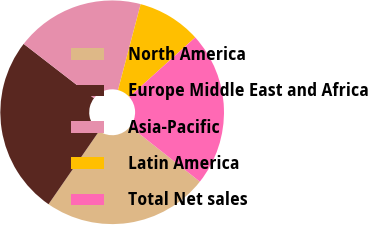Convert chart. <chart><loc_0><loc_0><loc_500><loc_500><pie_chart><fcel>North America<fcel>Europe Middle East and Africa<fcel>Asia-Pacific<fcel>Latin America<fcel>Total Net sales<nl><fcel>23.98%<fcel>25.84%<fcel>18.63%<fcel>9.23%<fcel>22.32%<nl></chart> 